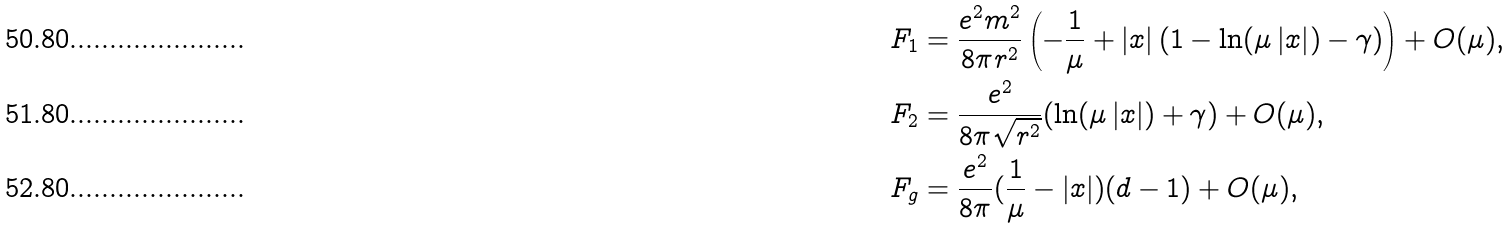Convert formula to latex. <formula><loc_0><loc_0><loc_500><loc_500>F _ { 1 } & = \frac { e ^ { 2 } m ^ { 2 } } { 8 \pi r ^ { 2 } } \left ( - \frac { 1 } { \mu } + \left | x \right | ( 1 - \ln ( \mu \left | x \right | ) - \gamma ) \right ) + O ( \mu ) , \\ F _ { 2 } & = \frac { e ^ { 2 } } { 8 \pi \sqrt { r ^ { 2 } } } ( \ln ( \mu \left | x \right | ) + \gamma ) + O ( \mu ) , \\ F _ { g } & = \frac { e ^ { 2 } } { 8 \pi } ( \frac { 1 } { \mu } - \left | x \right | ) ( d - 1 ) + O ( \mu ) ,</formula> 